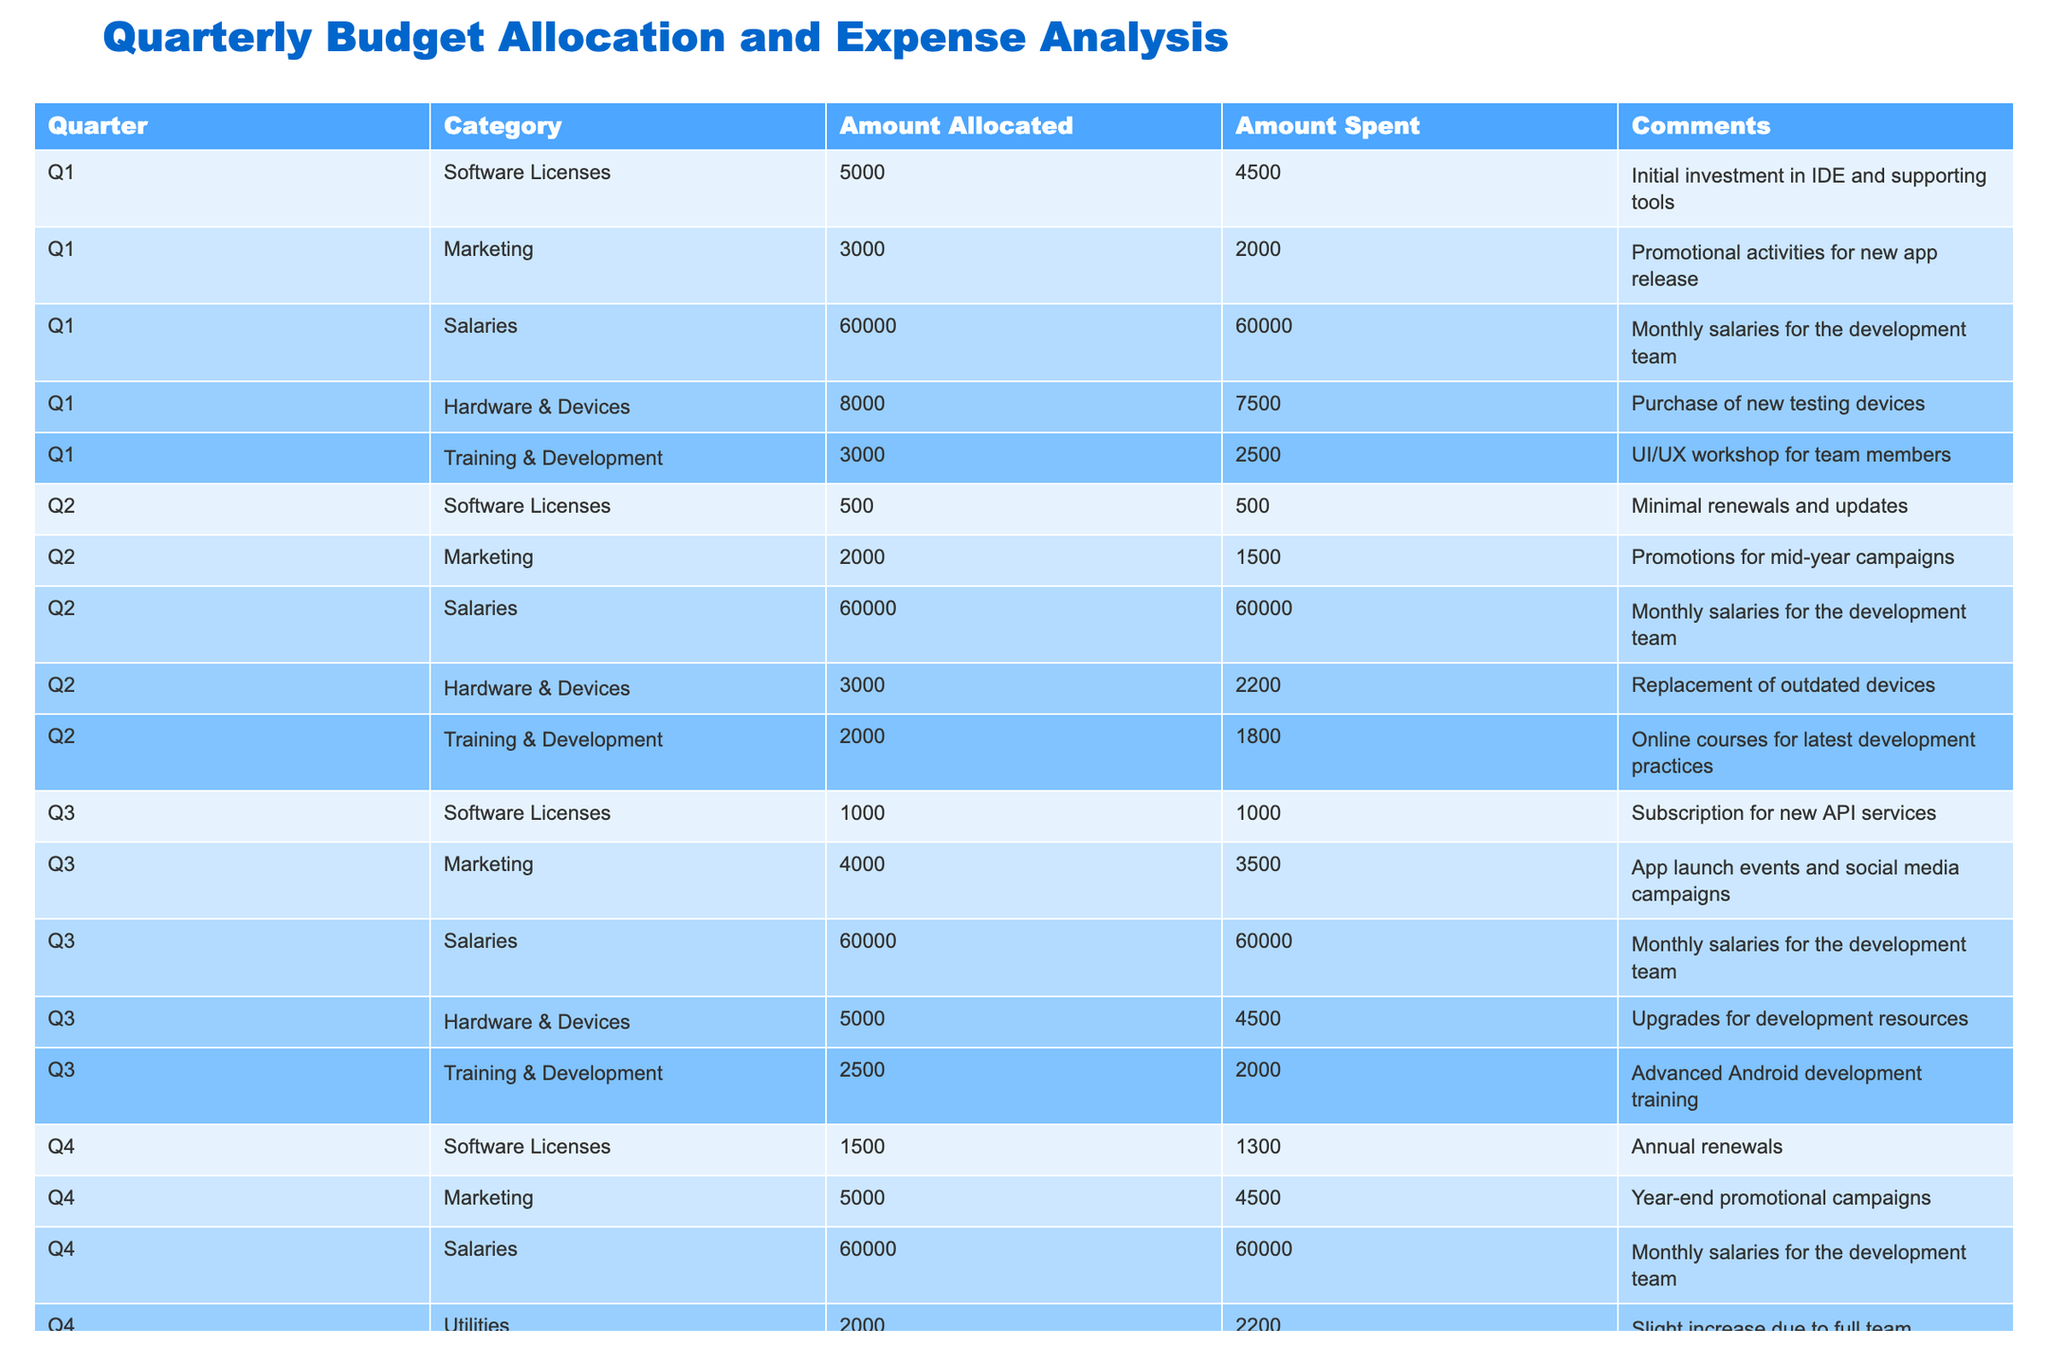What is the total amount allocated for Hardware & Devices across all quarters? By looking at the table, we can find the allocated amounts for Hardware & Devices for each quarter: Q1 is 8000, Q2 is 3000, Q3 is 5000, and Q4 is 7000. Adding these amounts together gives us 8000 + 3000 + 5000 + 7000 = 23000.
Answer: 23000 Was the amount spent on Software Licenses in Q3 higher or lower than that in Q4? In Q3, the amount spent on Software Licenses is 1000, and in Q4, it is 1300. Since 1000 is less than 1300, it shows that the amount spent in Q3 was lower than that in Q4.
Answer: Lower What is the total amount spent on Salaries for the entire year? The table states that the Salaries spent in each quarter are all 60000. Since there are 4 quarters, we sum them up as 60000 + 60000 + 60000 + 60000 = 240000.
Answer: 240000 In which quarter was the highest amount spent on Marketing, and what was that amount? From the table, we can see the spending amounts on Marketing: Q1 is 2000, Q2 is 1500, Q3 is 3500, and Q4 is 4500. Q4 has the highest spending of 4500. Hence, the highest amount spent was in Q4.
Answer: Q4, 4500 Is it true that the total allocated amount for Training & Development was less than the total allocated for Marketing? The total allocated amount for Training & Development is 3000 (Q1) + 2000 (Q2) + 2500 (Q3) + 3000 (Q4) = 10500. For Marketing, it is 3000 (Q1) + 2000 (Q2) + 4000 (Q3) + 5000 (Q4) = 14000. Since 10500 is less than 14000, the statement is true.
Answer: True What is the average amount spent on Hardware & Devices across all quarters? The spent amounts are Q1: 7500, Q2: 2200, Q3: 4500, and Q4: 6600. We first sum these amounts: 7500 + 2200 + 4500 + 6600 = 20800. Then, we divide by the number of quarters (4) for an average: 20800 / 4 = 5200.
Answer: 5200 Which category in Q2 had the least amount spent, and what was that amount? In Q2, the spent amounts for each category are: Software Licenses 500, Marketing 1500, Salaries 60000, Hardware & Devices 2200, and Training & Development 1800. The smallest value here is 500 from Software Licenses.
Answer: Software Licenses, 500 What was the increase in the amount spent on Utilities from Q4 compared to Q3? The table shows that Utilities were not mentioned in Q3 but in Q4, the amount spent is 2200. Since there was no amount in Q3, we can say the increase from 0 to 2200 is 2200.
Answer: 2200 